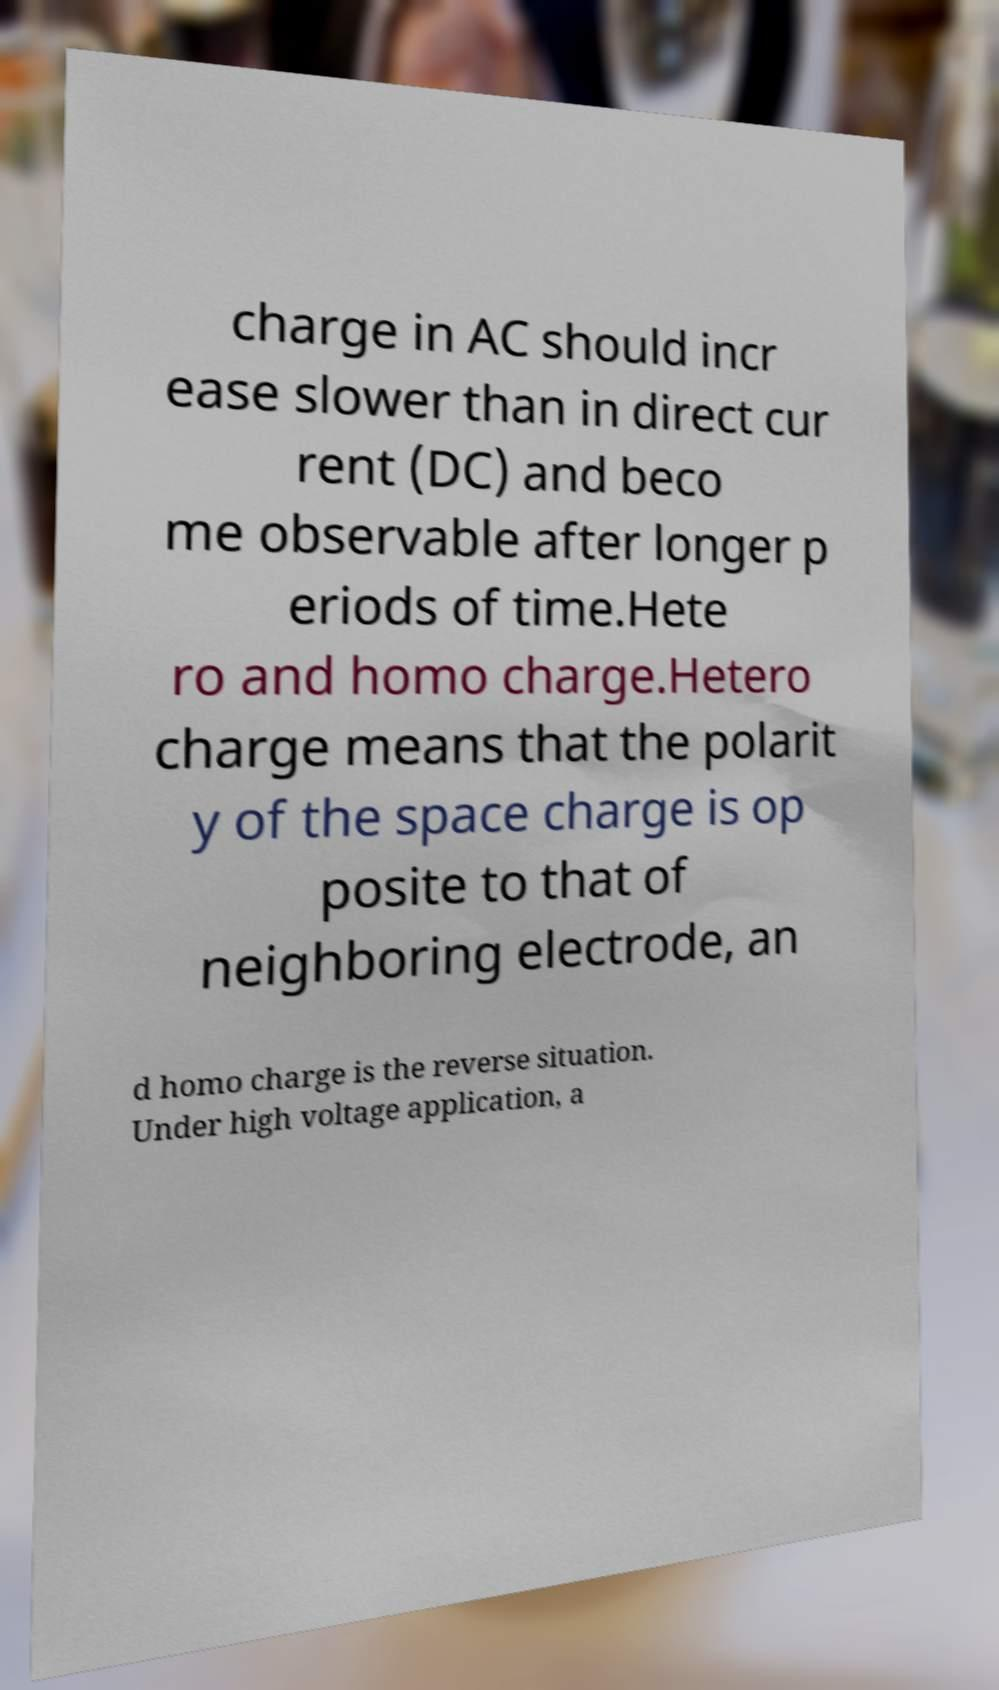Can you accurately transcribe the text from the provided image for me? charge in AC should incr ease slower than in direct cur rent (DC) and beco me observable after longer p eriods of time.Hete ro and homo charge.Hetero charge means that the polarit y of the space charge is op posite to that of neighboring electrode, an d homo charge is the reverse situation. Under high voltage application, a 